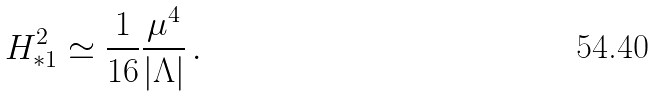<formula> <loc_0><loc_0><loc_500><loc_500>H ^ { 2 } _ { * 1 } \simeq \frac { 1 } { 1 6 } \frac { \mu ^ { 4 } } { | \Lambda | } \, .</formula> 